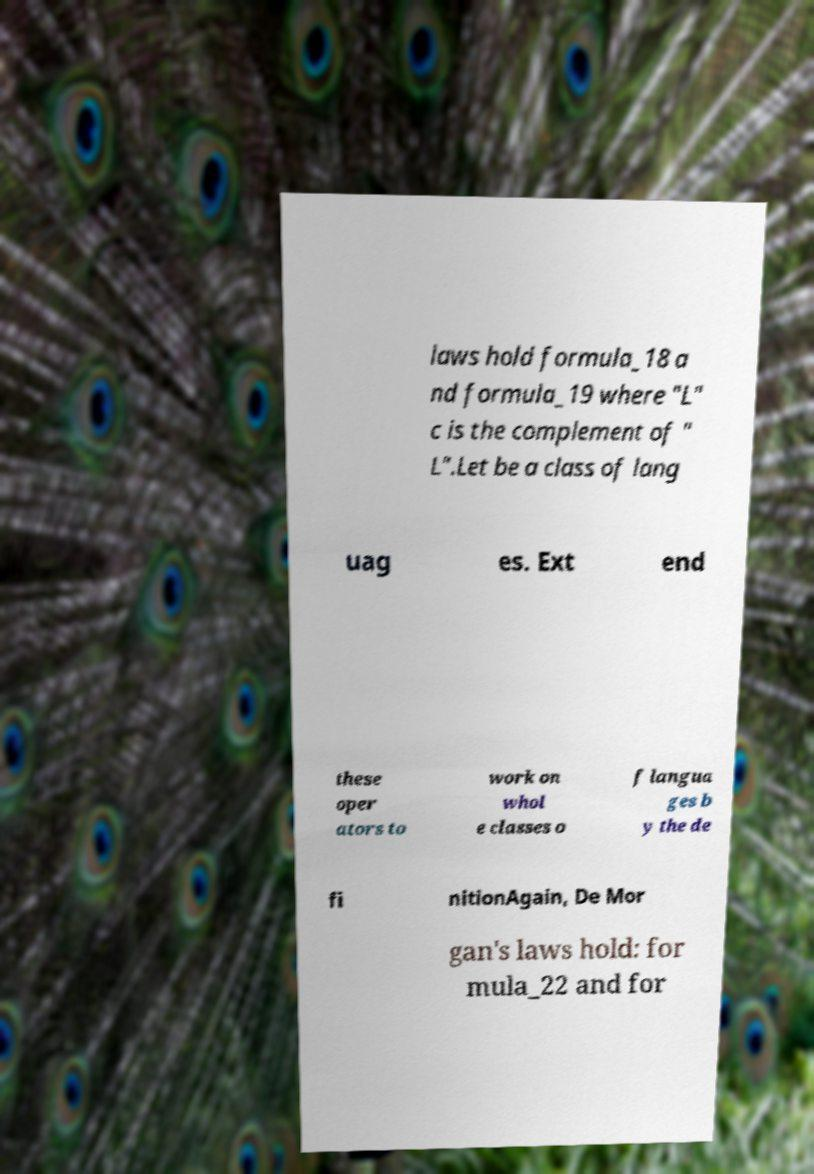For documentation purposes, I need the text within this image transcribed. Could you provide that? laws hold formula_18 a nd formula_19 where "L" c is the complement of " L".Let be a class of lang uag es. Ext end these oper ators to work on whol e classes o f langua ges b y the de fi nitionAgain, De Mor gan's laws hold: for mula_22 and for 